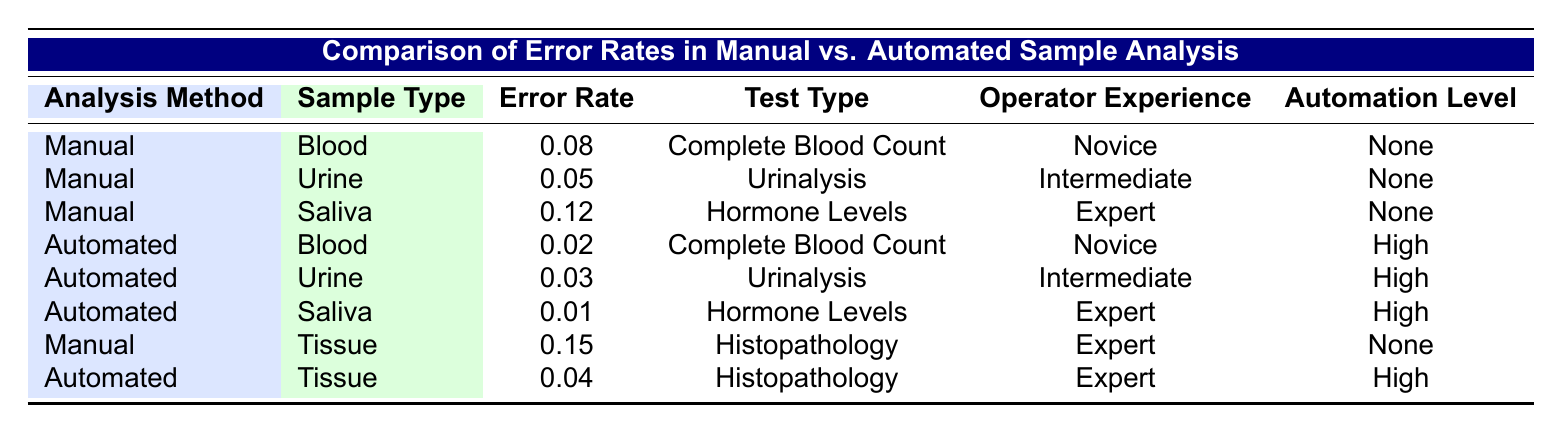What is the error rate for automated saliva analysis? The error rate for automated saliva analysis is found in the row with "Automated" under the "Analysis Method" and "Saliva" under the "Sample Type." The corresponding error rate is 0.01.
Answer: 0.01 Which analysis method has the highest error rate for tissue samples? The error rate for manual tissue analysis is 0.15, while the automated tissue analysis error rate is 0.04. Since 0.15 is higher than 0.04, the manual method has the highest error rate for tissue samples.
Answer: Manual What is the overall average error rate for manual sample analysis? To calculate the average error rate for manual analysis, sum the error rates: (0.08 + 0.05 + 0.12 + 0.15) = 0.40. There are 4 manual analysis samples, so the average is 0.40/4 = 0.10.
Answer: 0.10 Is the error rate for automated blood analysis lower than that for manual blood analysis? The error rate for automated blood analysis is 0.02, while for manual blood analysis, it is 0.08. Since 0.02 is less than 0.08, the answer is yes, the automated method has a lower error rate.
Answer: Yes What is the difference in error rates between automated and manual analysis for urinalysis? The error rate for manual urinalysis is 0.05 and for automated urinalysis is 0.03. To find the difference, subtract: 0.05 - 0.03 = 0.02.
Answer: 0.02 Are there any analysis methods with the same error rates for different sample types? Reviewing the table, the error rates for different samples are distinct, such as manual blood (0.08) and automated blood (0.02), which have different rates. Similarly, all other pairs also differ in error rates. Thus, the answer is no, there are no methods with the same error rates across different sample types.
Answer: No How many samples in total have an error rate of 0.03 or lower? The samples with an error rate of 0.03 or lower are automated urine (0.03), automated saliva (0.01), and automated tissue (0.04). This gives us 3 samples.
Answer: 3 What is the error rate for hormone levels analysis when using the manual method compared to the automated method? The error rate for manual hormone levels analysis is 0.12 and for automated hormone levels analysis, it is 0.01. Comparing both shows that 0.12 is higher than 0.01, indicating that the manual method has a higher error rate for hormone levels analysis.
Answer: Manual method is higher 